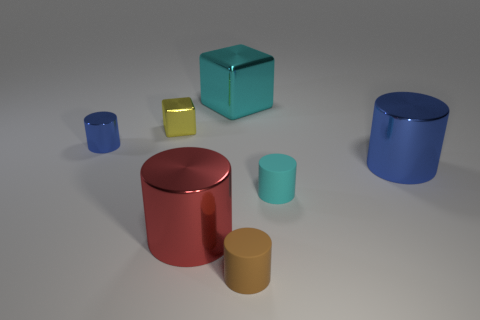Is the material of the block left of the big cube the same as the cyan thing that is on the right side of the small brown matte object?
Give a very brief answer. No. There is a tiny rubber object that is the same color as the large block; what is its shape?
Provide a short and direct response. Cylinder. There is a big thing in front of the cyan matte cylinder; what material is it?
Ensure brevity in your answer.  Metal. How many tiny yellow matte things have the same shape as the big red shiny object?
Keep it short and to the point. 0. What shape is the thing that is made of the same material as the small brown cylinder?
Your response must be concise. Cylinder. What is the shape of the matte object behind the rubber thing left of the small cyan rubber object that is in front of the tiny yellow cube?
Provide a short and direct response. Cylinder. Are there more small cyan rubber cylinders than green shiny things?
Your response must be concise. Yes. There is a small brown object that is the same shape as the tiny blue object; what is its material?
Provide a short and direct response. Rubber. Is the material of the brown thing the same as the tiny blue thing?
Offer a terse response. No. Is the number of big cyan cubes that are right of the big red cylinder greater than the number of big blue cubes?
Your answer should be compact. Yes. 